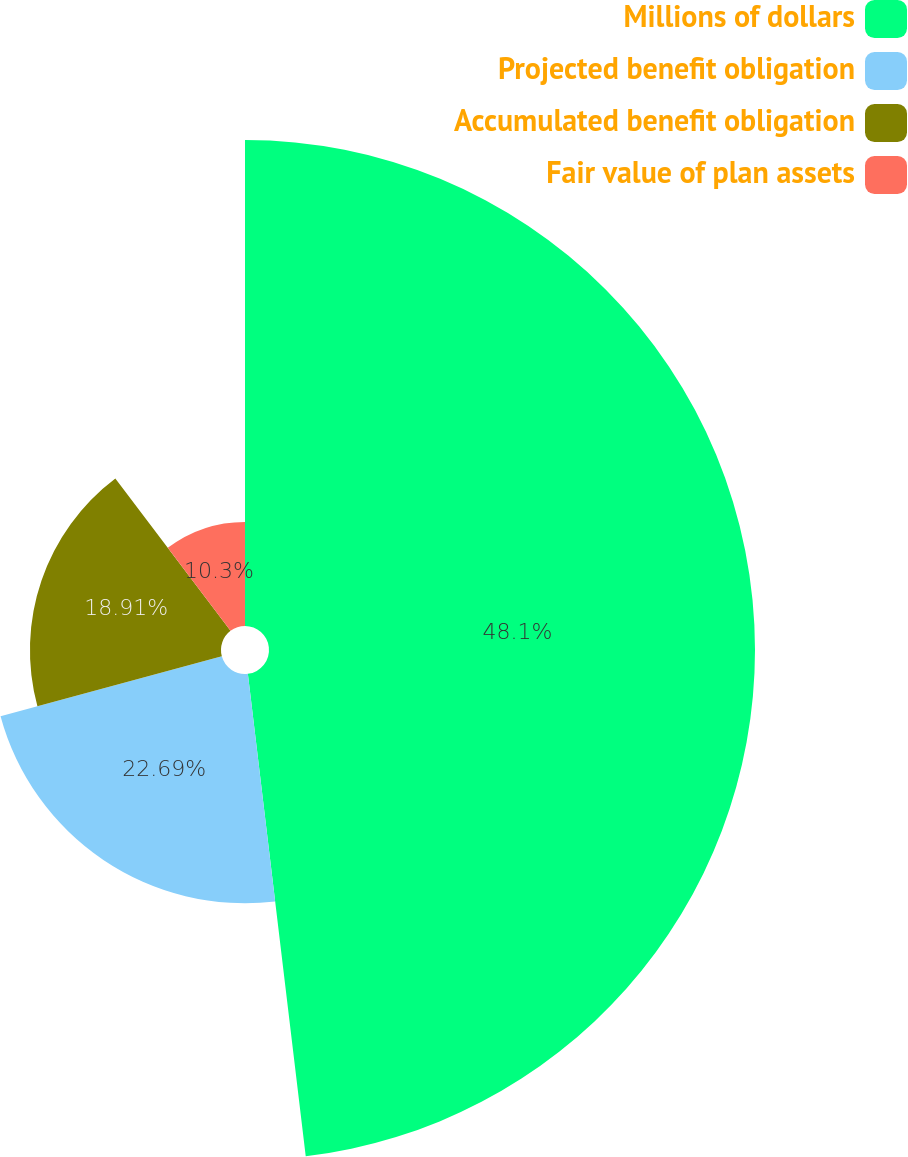Convert chart to OTSL. <chart><loc_0><loc_0><loc_500><loc_500><pie_chart><fcel>Millions of dollars<fcel>Projected benefit obligation<fcel>Accumulated benefit obligation<fcel>Fair value of plan assets<nl><fcel>48.1%<fcel>22.69%<fcel>18.91%<fcel>10.3%<nl></chart> 